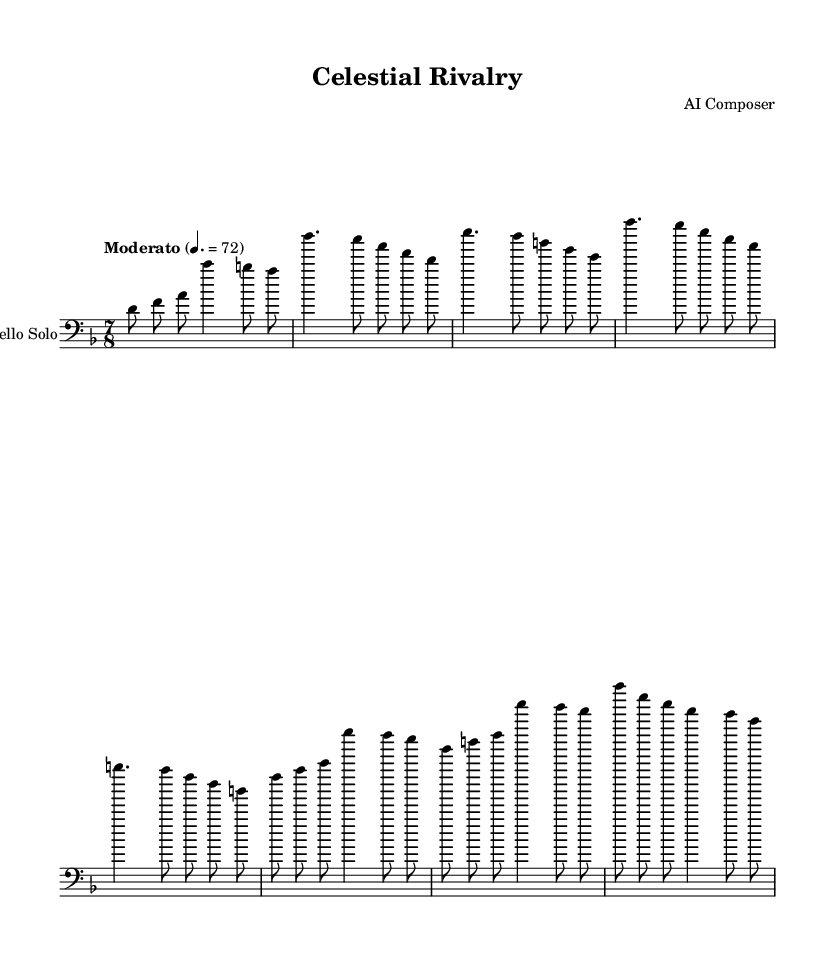What is the time signature of this music? The time signature is found at the beginning of the sheet music. It is indicated as 7/8, meaning that there are seven beats per measure, and an eighth note gets one beat.
Answer: 7/8 What is the key signature of the piece? The key signature is also indicated at the beginning of the music and is represented by the presence of one flat, which corresponds to the key of D minor, as there are no sharps indicated.
Answer: D minor What is the tempo marking of the piece? The tempo marking is shown above the staff with a directive for the speed of the piece. It states "Moderato" followed by a metronome marking of 4. = 72, indicating a moderate pace.
Answer: Moderato What is the first note of the Cello Solo? The first note is found at the beginning of the cello line, which is a D note indicated by the second line of the bass clef.
Answer: D How many measures are in the provided excerpt? To determine the number of measures, we count the bar lines in the provided section of the music. Each section (Intro, Verse, etc.) is labeled, and by examining the notation we see there are 6 measures present.
Answer: 6 What type of orchestral element is suggested in this Experimental R&B? To assess the orchestral influence, we consider the overall arrangement and structure of the music. The integration of unconventional meters with a solo cello implies the use of rich textures, which indicates strings or orchestral instruments likely in the background.
Answer: Strings Which section includes the bridge? The bridge is marked within the structure of the sheet music and is indicated as “Bridge” in the notation, explicitly separating it from other sections like Intro, Verse, and Chorus.
Answer: Bridge 